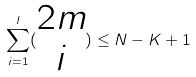<formula> <loc_0><loc_0><loc_500><loc_500>\sum _ { i = 1 } ^ { l } ( \begin{matrix} 2 m \\ i \end{matrix} ) \leq N - K + 1</formula> 